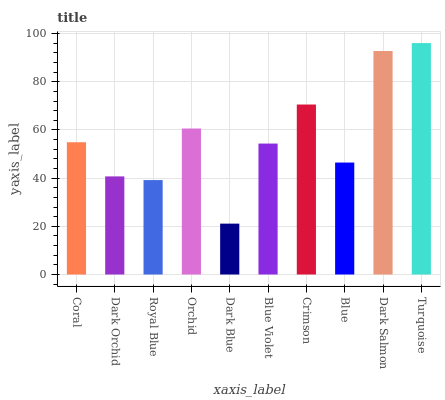Is Dark Blue the minimum?
Answer yes or no. Yes. Is Turquoise the maximum?
Answer yes or no. Yes. Is Dark Orchid the minimum?
Answer yes or no. No. Is Dark Orchid the maximum?
Answer yes or no. No. Is Coral greater than Dark Orchid?
Answer yes or no. Yes. Is Dark Orchid less than Coral?
Answer yes or no. Yes. Is Dark Orchid greater than Coral?
Answer yes or no. No. Is Coral less than Dark Orchid?
Answer yes or no. No. Is Coral the high median?
Answer yes or no. Yes. Is Blue Violet the low median?
Answer yes or no. Yes. Is Orchid the high median?
Answer yes or no. No. Is Dark Salmon the low median?
Answer yes or no. No. 